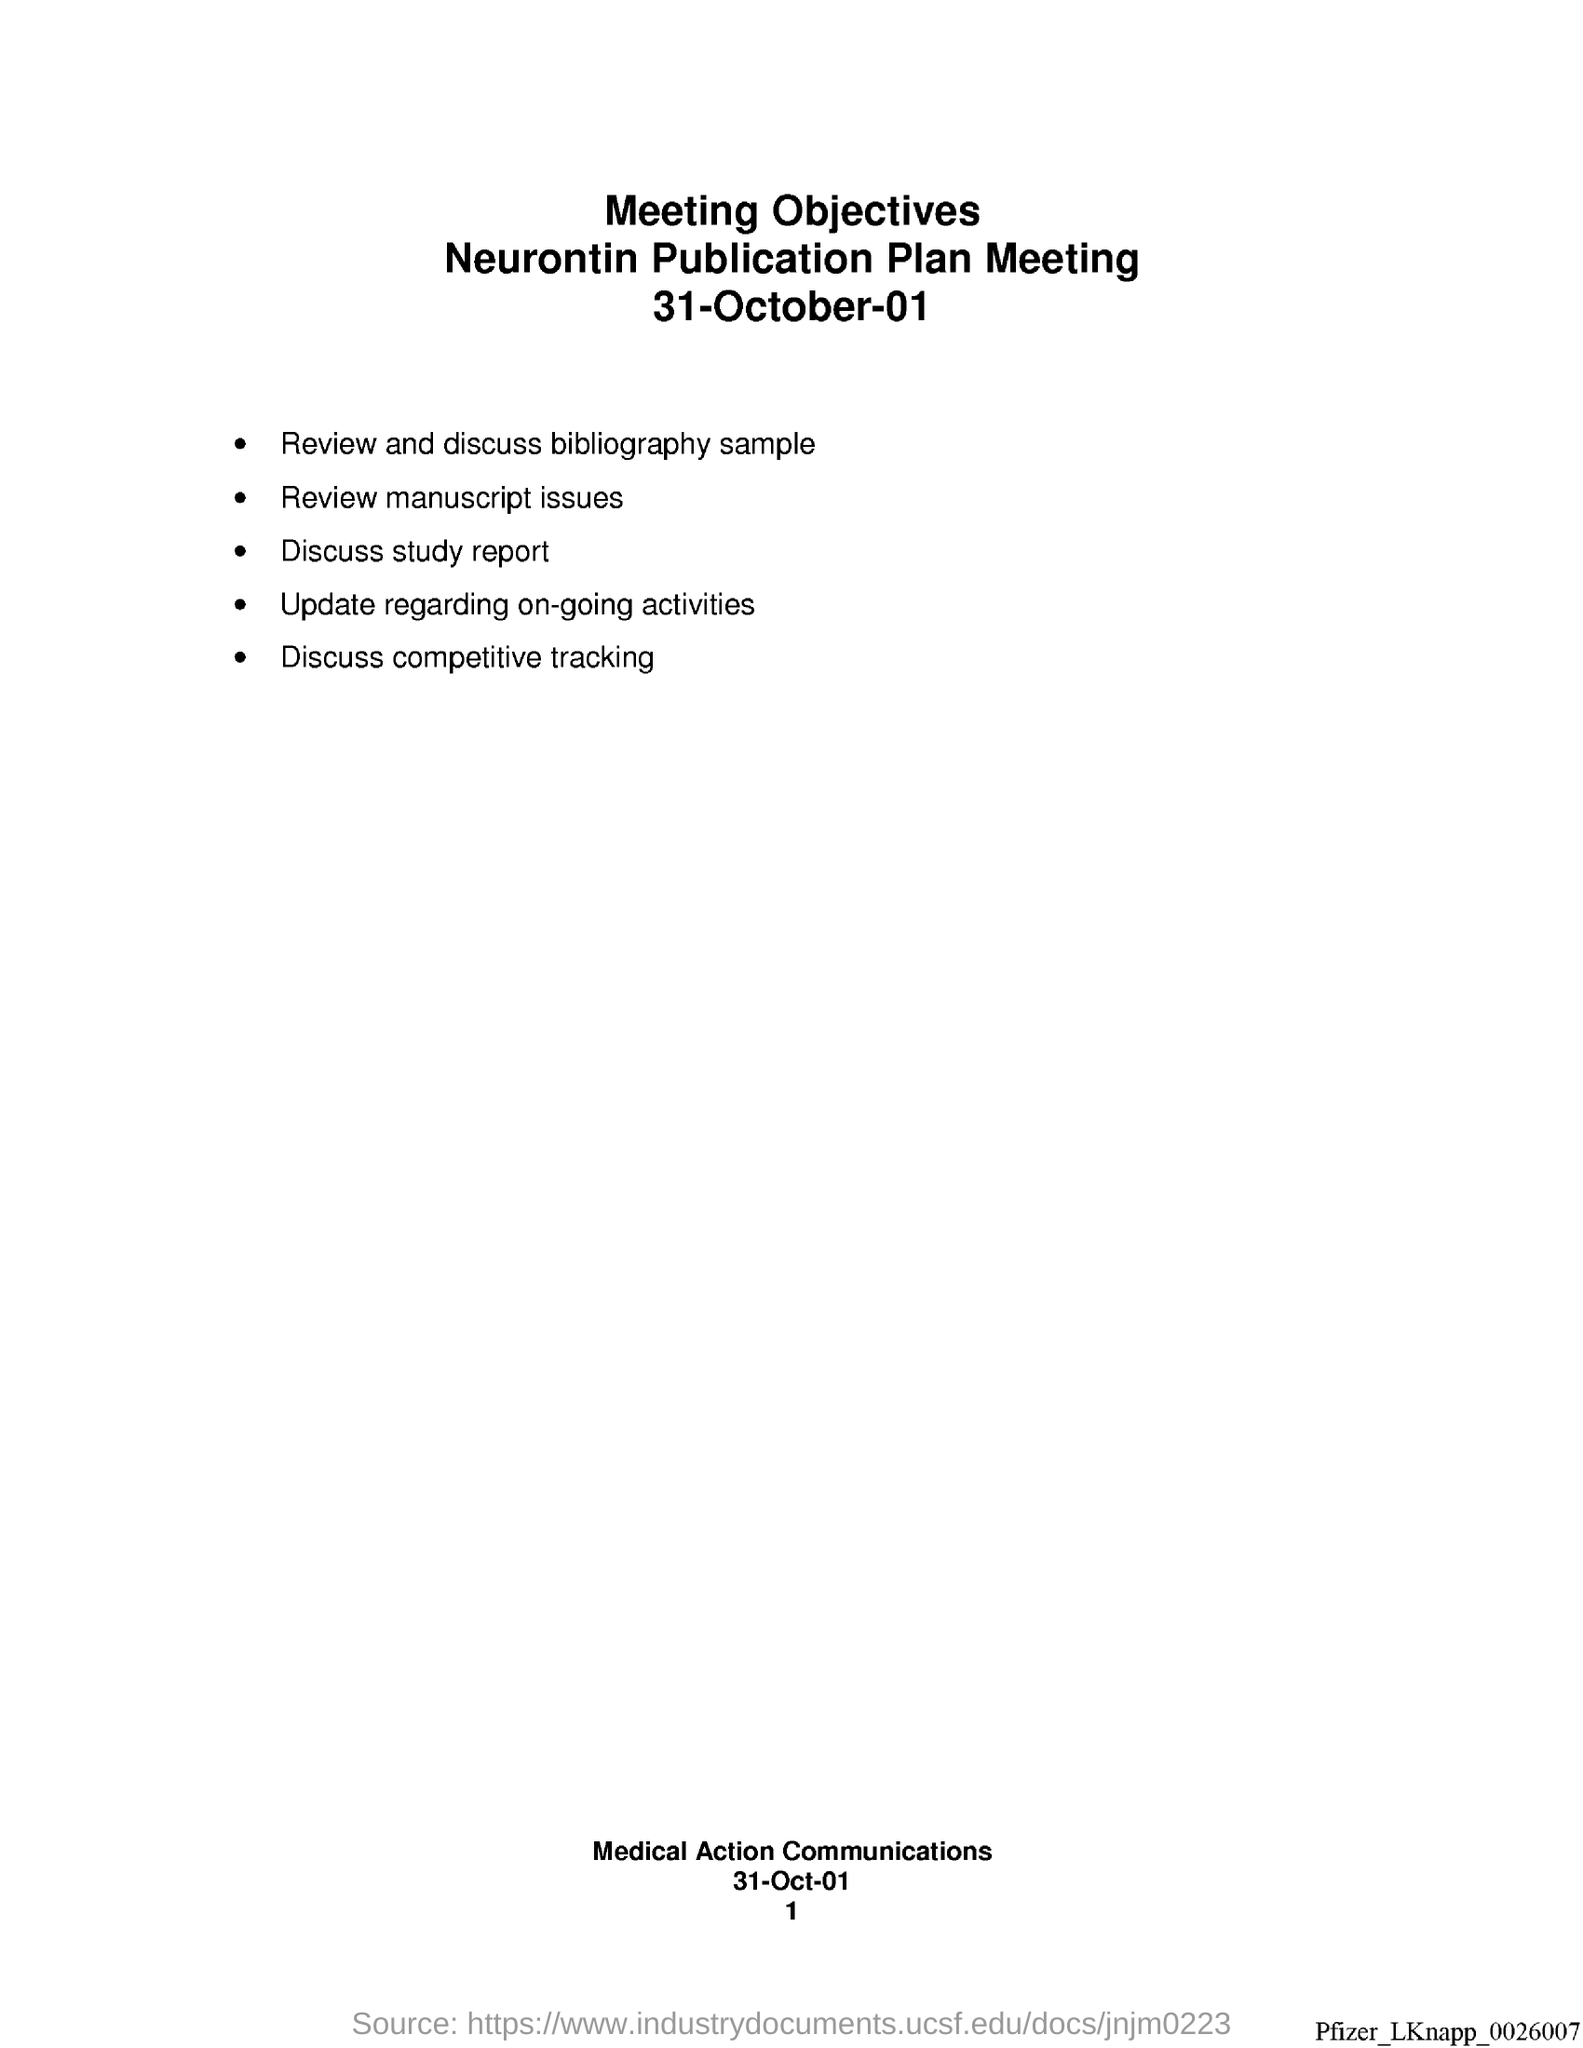Highlight a few significant elements in this photo. To determine the page number at the bottom of the page, I used the range function from 1 to... The date at the bottom of the page is 31st of October in the year 2001. 